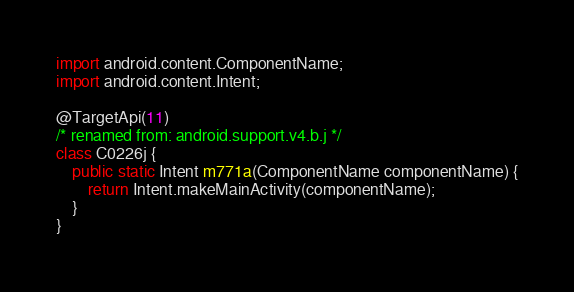<code> <loc_0><loc_0><loc_500><loc_500><_Java_>import android.content.ComponentName;
import android.content.Intent;

@TargetApi(11)
/* renamed from: android.support.v4.b.j */
class C0226j {
    public static Intent m771a(ComponentName componentName) {
        return Intent.makeMainActivity(componentName);
    }
}
</code> 